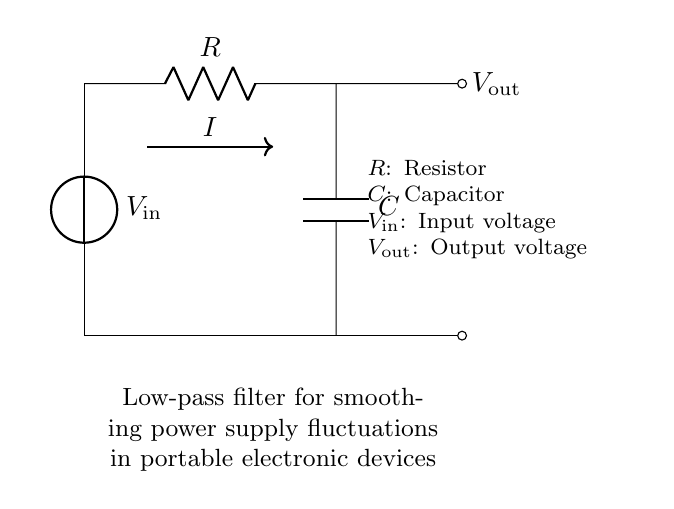What components are present in the circuit? The circuit contains a resistor and a capacitor, indicated by their symbols in the diagram.
Answer: Resistor and capacitor What is the output voltage labeled in the circuit? The output voltage is labeled as V_out in the circuit diagram, showing the point where the output is taken.
Answer: V_out What does the arrow indicating current I show? The arrow labeled I denotes the direction of current flow through the circuit from the voltage source to the resistor and capacitor.
Answer: Current direction What type of filter is represented by this circuit? This is a low-pass filter, as indicated in the description within the circuit diagram, which allows low-frequency signals to pass while attenuating higher frequencies.
Answer: Low-pass filter How does the capacitor affect the output voltage? The capacitor stores charge, smoothing out fluctuations in the output voltage by providing a steady voltage level under varying input conditions.
Answer: Smoothing voltage What happens to the output voltage if the resistance value is increased? Increasing resistance lowers the current flowing through the circuit and can lead to a slower charging time for the capacitor, affecting the smoothing effect on the output voltage.
Answer: Slower smoothing What is the function of the resistor in the filter circuit? The resistor limits current flow to the capacitor, impacting the time constant of the circuit and thus the cutoff frequency of the low-pass filter.
Answer: Current limitation 